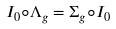Convert formula to latex. <formula><loc_0><loc_0><loc_500><loc_500>I _ { 0 } \circ \Lambda _ { g } = \Sigma _ { g } \circ I _ { 0 }</formula> 